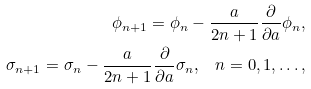<formula> <loc_0><loc_0><loc_500><loc_500>\phi _ { n + 1 } = \phi _ { n } - \frac { a } { 2 n + 1 } \frac { \partial } { \partial a } \phi _ { n } , \\ \sigma _ { n + 1 } = \sigma _ { n } - \frac { a } { 2 n + 1 } \frac { \partial } { \partial a } \sigma _ { n } \text {,} \quad n = 0 , 1 , \dots ,</formula> 